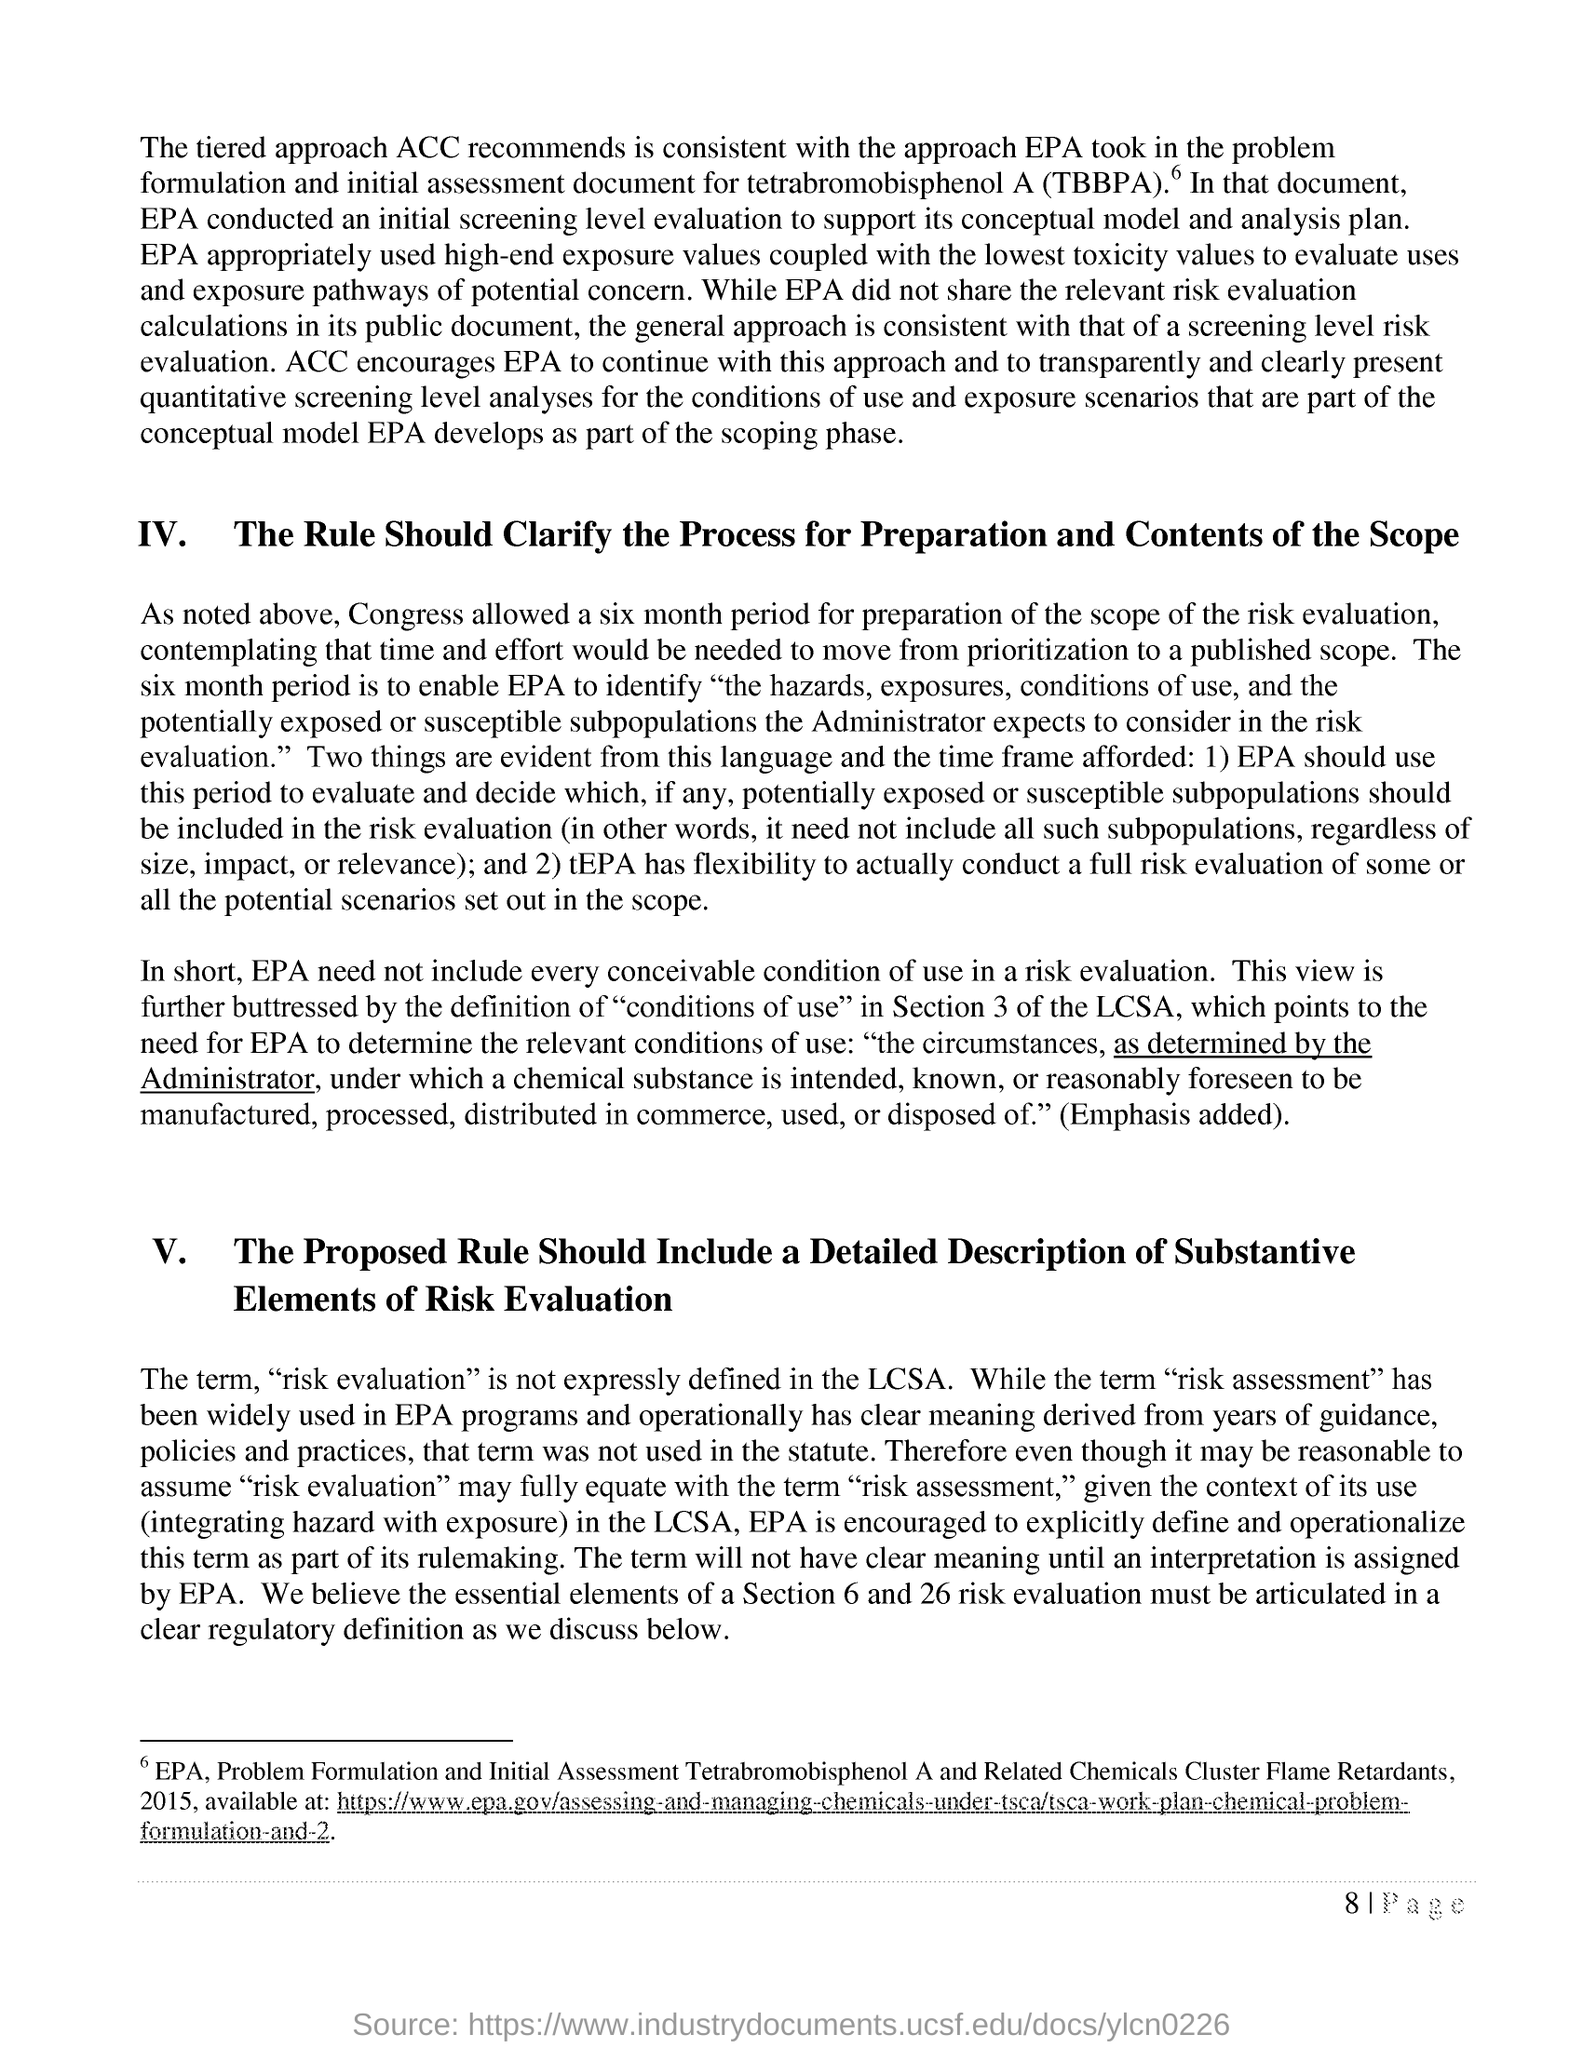Which term wasn't expressly defined in the LCSA based on last paragaraph of document??
Ensure brevity in your answer.  Risk evaluation. What is the abbreviated word for "tetrabromobisphenol A" specified in brackets?
Provide a succinct answer. TBBPA. 